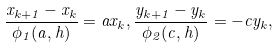Convert formula to latex. <formula><loc_0><loc_0><loc_500><loc_500>\frac { x _ { k + 1 } - x _ { k } } { \phi _ { 1 } ( a , h ) } = a x _ { k } , \frac { y _ { k + 1 } - y _ { k } } { \phi _ { 2 } ( c , h ) } = - c y _ { k } ,</formula> 